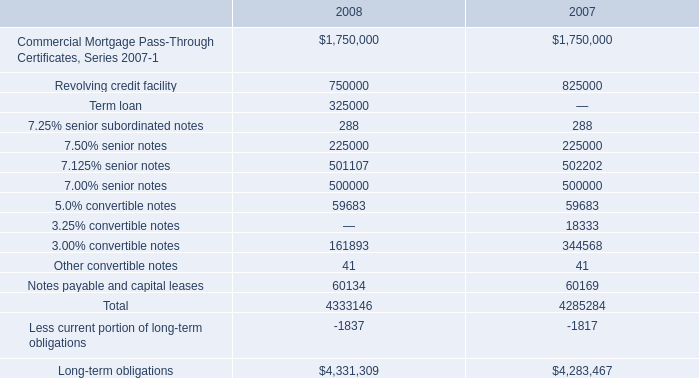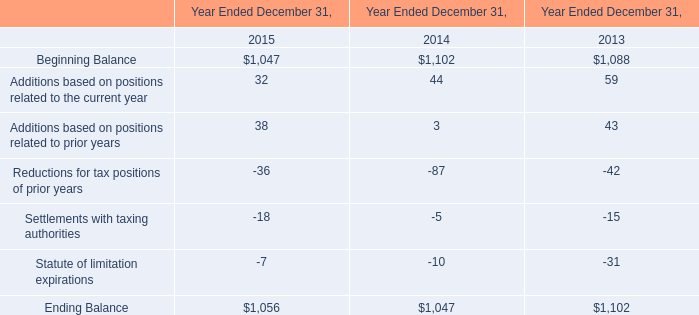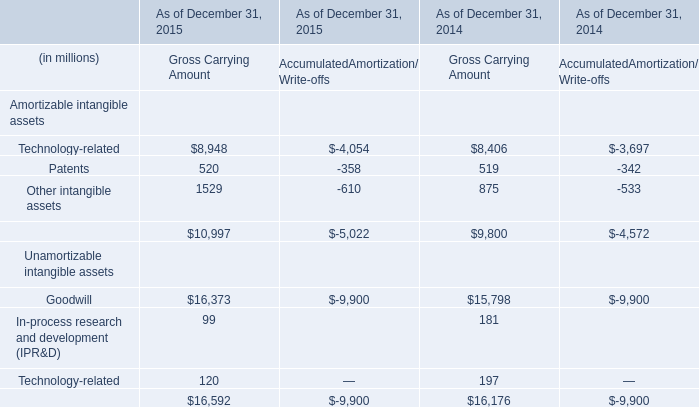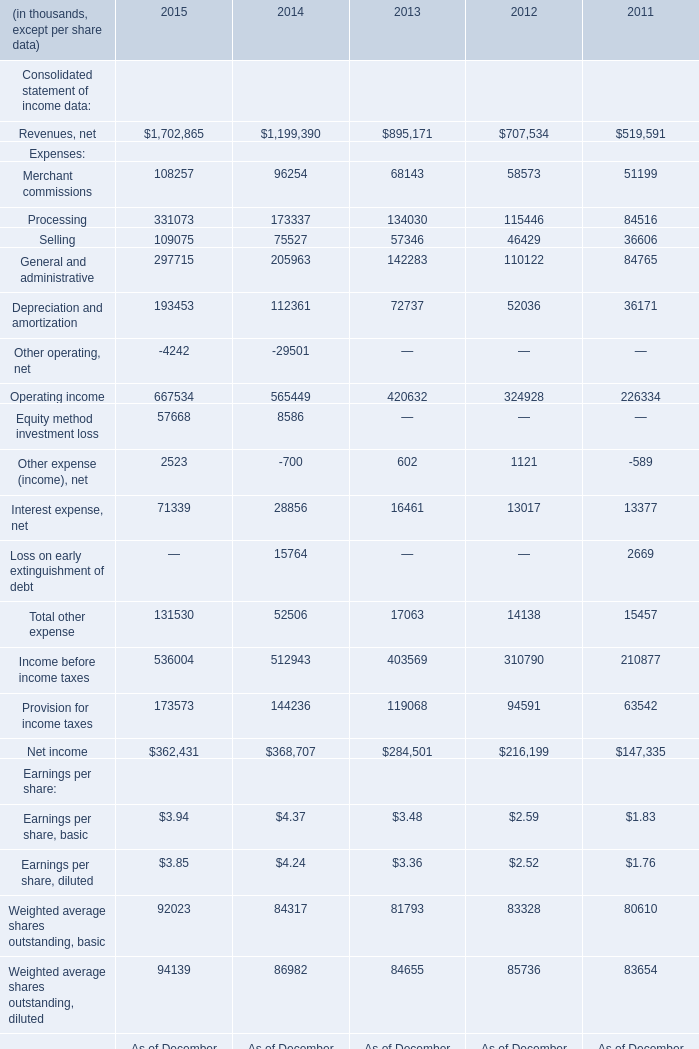What's the average of Patents Gross Carrying Amount in 2015? (in millions) 
Answer: 520. 